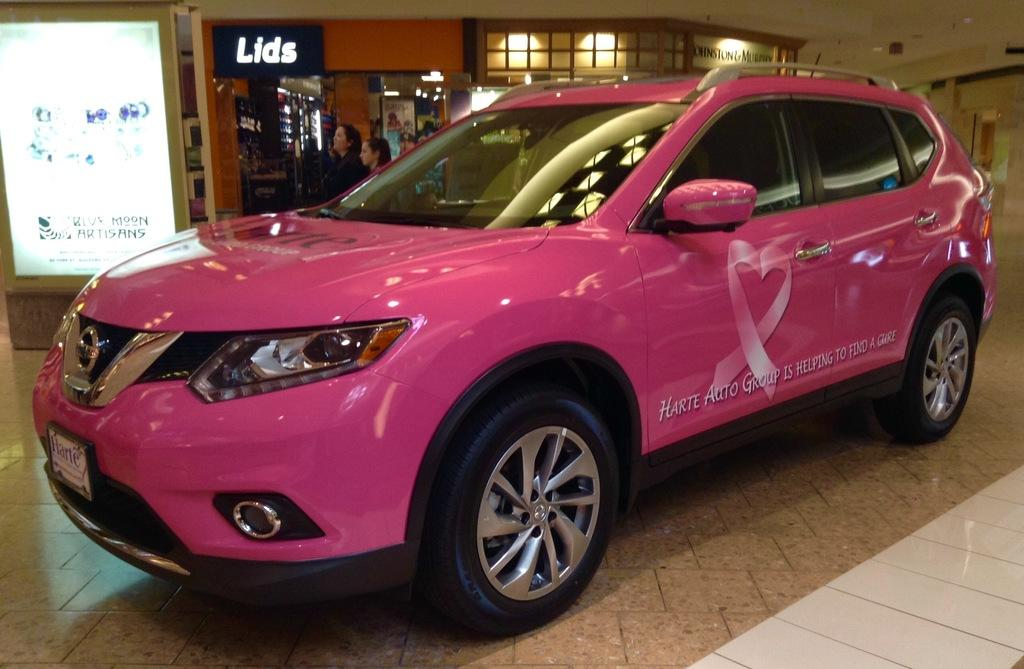What color is the car in the image? The car in the image is pink. What is at the bottom of the image? There is a floor at the bottom of the image. What can be seen in the background of the image? There is a board in the background of the image. How many people are in the image? There are many people in the image. Where are the chickens kept in the image? There are no chickens present in the image. What type of crate is used to store the wilderness in the image? There is no crate or wilderness present in the image. 